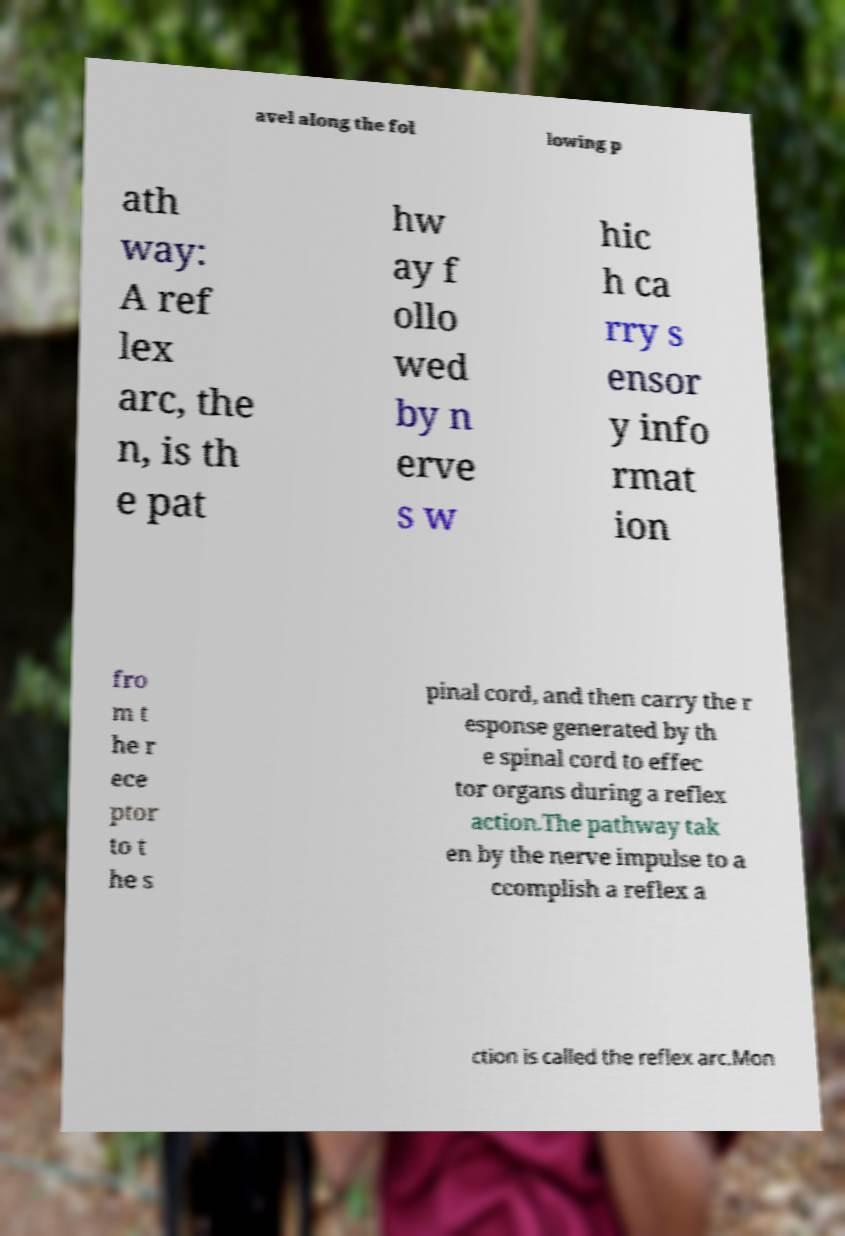For documentation purposes, I need the text within this image transcribed. Could you provide that? avel along the fol lowing p ath way: A ref lex arc, the n, is th e pat hw ay f ollo wed by n erve s w hic h ca rry s ensor y info rmat ion fro m t he r ece ptor to t he s pinal cord, and then carry the r esponse generated by th e spinal cord to effec tor organs during a reflex action.The pathway tak en by the nerve impulse to a ccomplish a reflex a ction is called the reflex arc.Mon 